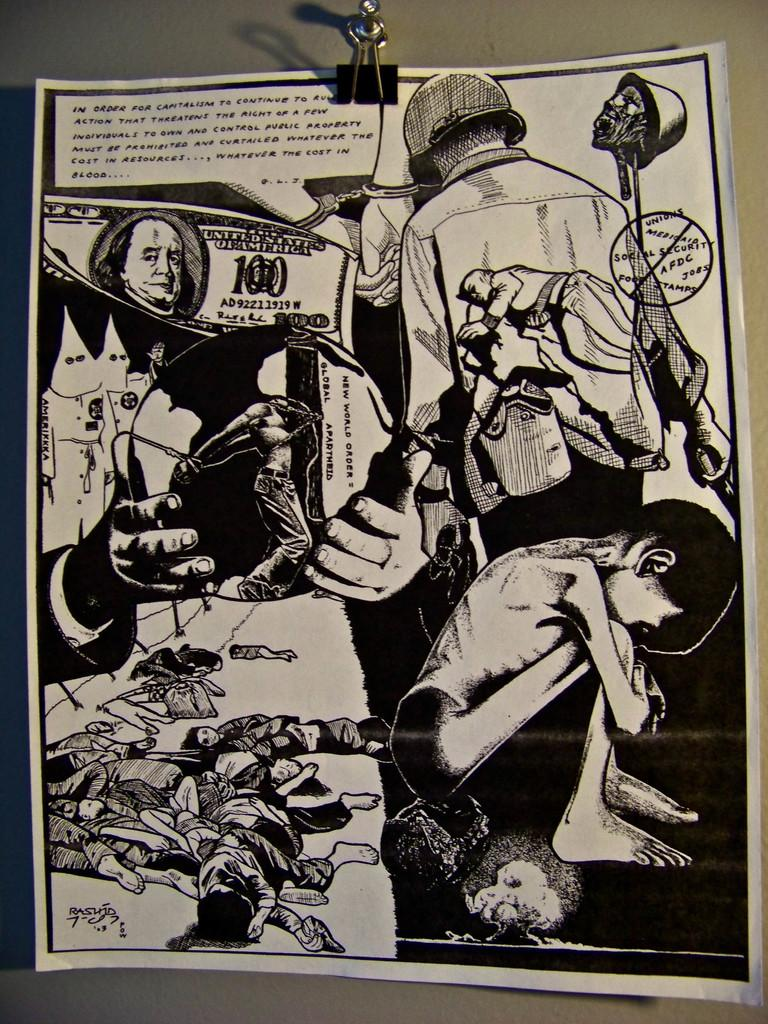<image>
Describe the image concisely. A 100 dollar bill from the United States of America sits on a black and white poster 